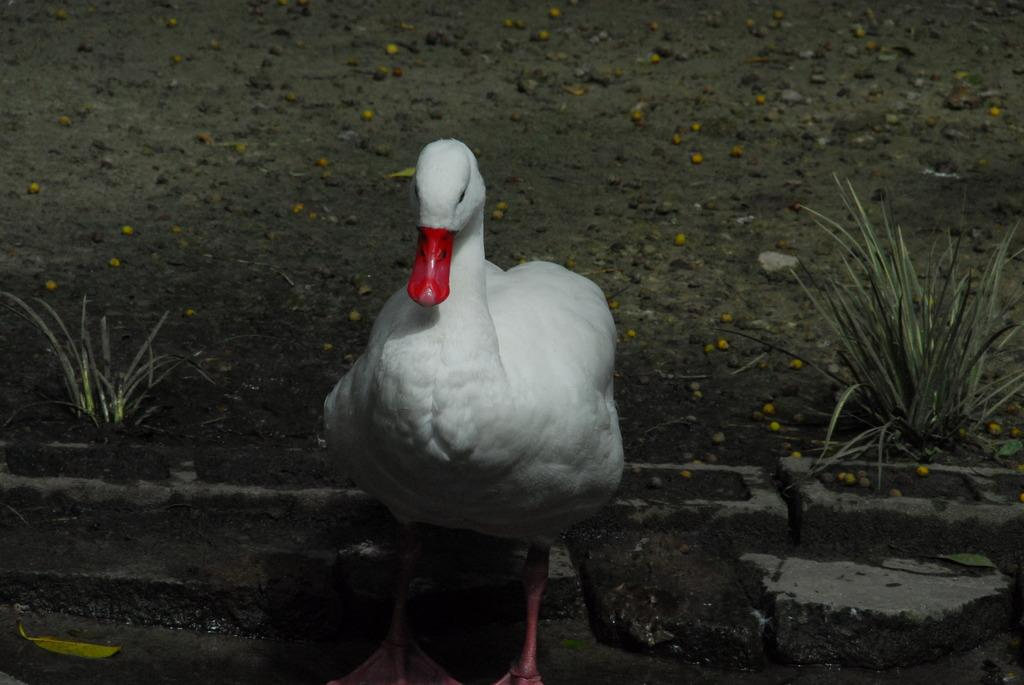What type of animal is in the image? There is a duck in the image. What else can be seen in the image besides the duck? There are plants in the image. Are there any objects on the ground in the image? Yes, there are objects on the ground in the image. What type of competition is taking place in the image? There is no competition present in the image; it features a duck, plants, and objects on the ground. What meal or lunch is being prepared in the image? There is no meal or lunch preparation visible in the image. 